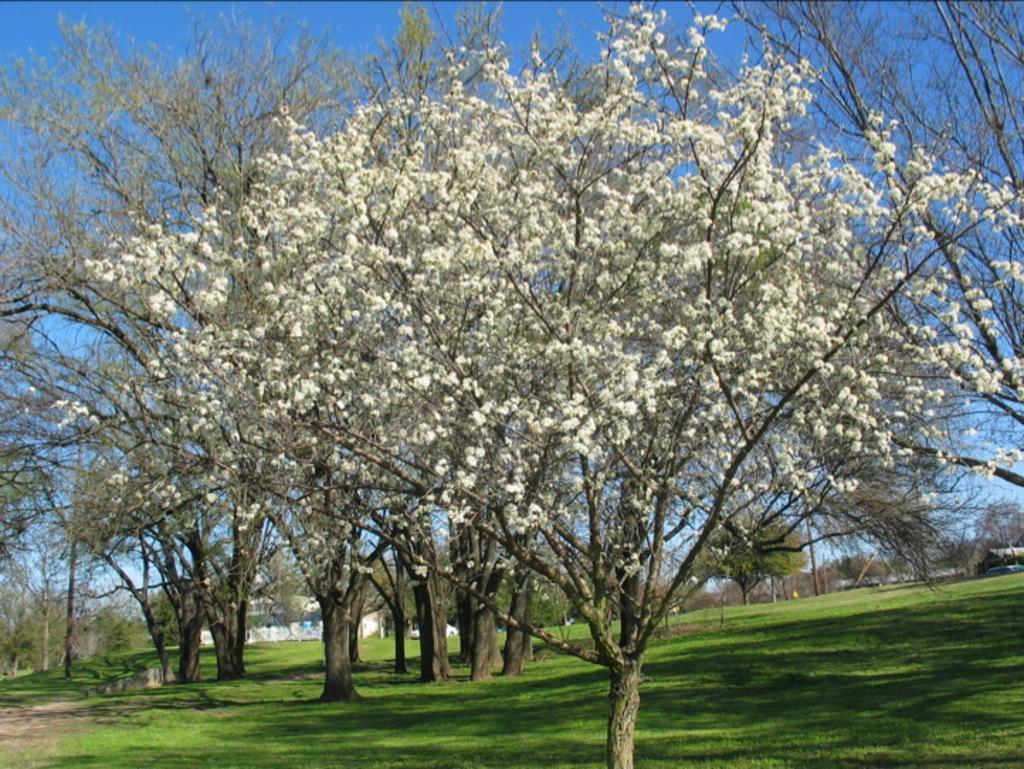Could you give a brief overview of what you see in this image? In this picture we can see grass at the bottom, there are some trees and leaves here, we can see the sky at the top of the picture. 